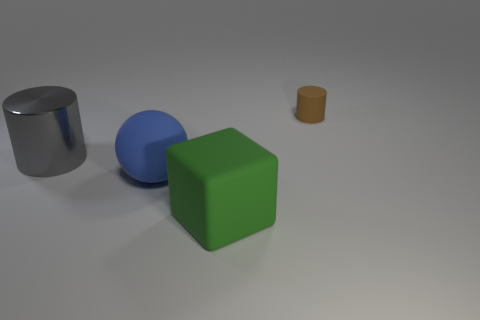Add 4 small rubber objects. How many objects exist? 8 Subtract 1 gray cylinders. How many objects are left? 3 Subtract all balls. How many objects are left? 3 Subtract all cyan balls. Subtract all green cubes. How many balls are left? 1 Subtract all green spheres. How many yellow cylinders are left? 0 Subtract all large yellow balls. Subtract all cylinders. How many objects are left? 2 Add 4 tiny brown cylinders. How many tiny brown cylinders are left? 5 Add 1 blue spheres. How many blue spheres exist? 2 